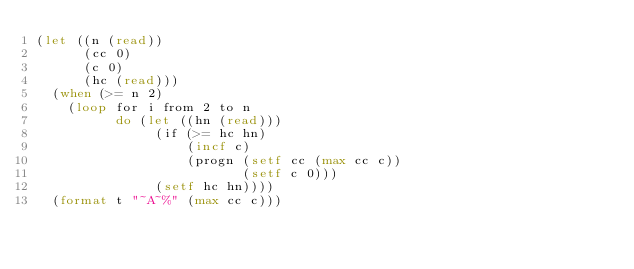<code> <loc_0><loc_0><loc_500><loc_500><_Lisp_>(let ((n (read))
      (cc 0)
      (c 0)
      (hc (read)))
  (when (>= n 2)
    (loop for i from 2 to n
          do (let ((hn (read)))
               (if (>= hc hn)
                   (incf c)
                   (progn (setf cc (max cc c))
                          (setf c 0)))
               (setf hc hn))))
  (format t "~A~%" (max cc c)))</code> 